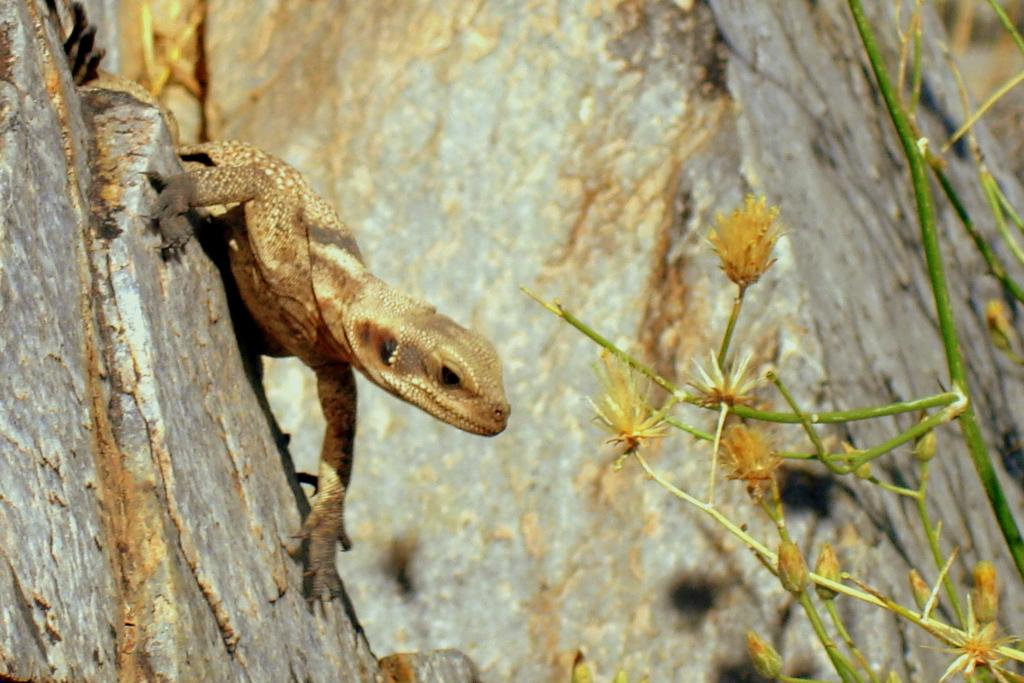What type of animal is on the surface in the image? There is a reptile on the surface in the image. What other living organisms can be seen in the image? There are plants, flowers, and buds in the image. What is the background of the image? There is a rock in the background of the image. What type of nerve can be seen in the image? There is no nerve present in the image; it features a reptile, plants, flowers, buds, and a rock. Can you tell me how the reptile is performing a trick in the image? The image does not depict the reptile performing any tricks. 